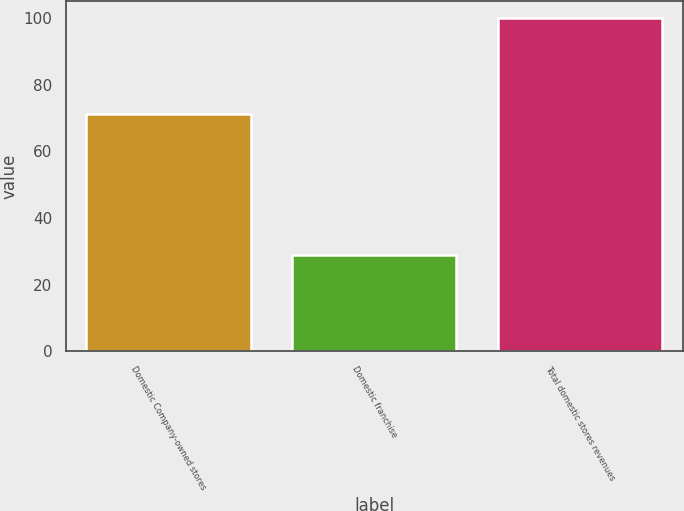Convert chart. <chart><loc_0><loc_0><loc_500><loc_500><bar_chart><fcel>Domestic Company-owned stores<fcel>Domestic franchise<fcel>Total domestic stores revenues<nl><fcel>71.2<fcel>28.8<fcel>100<nl></chart> 